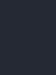<code> <loc_0><loc_0><loc_500><loc_500><_YAML_>
</code> 